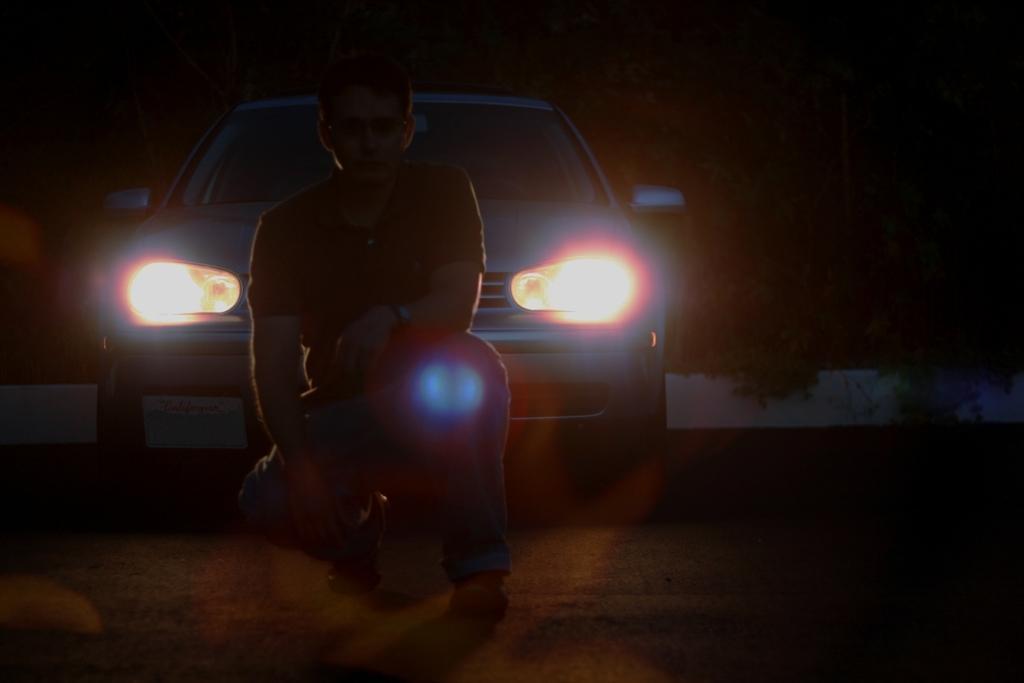Can you describe this image briefly? In this image I can see the person. In the background I can see the vehicle and I can also see the vehicle head lights. 